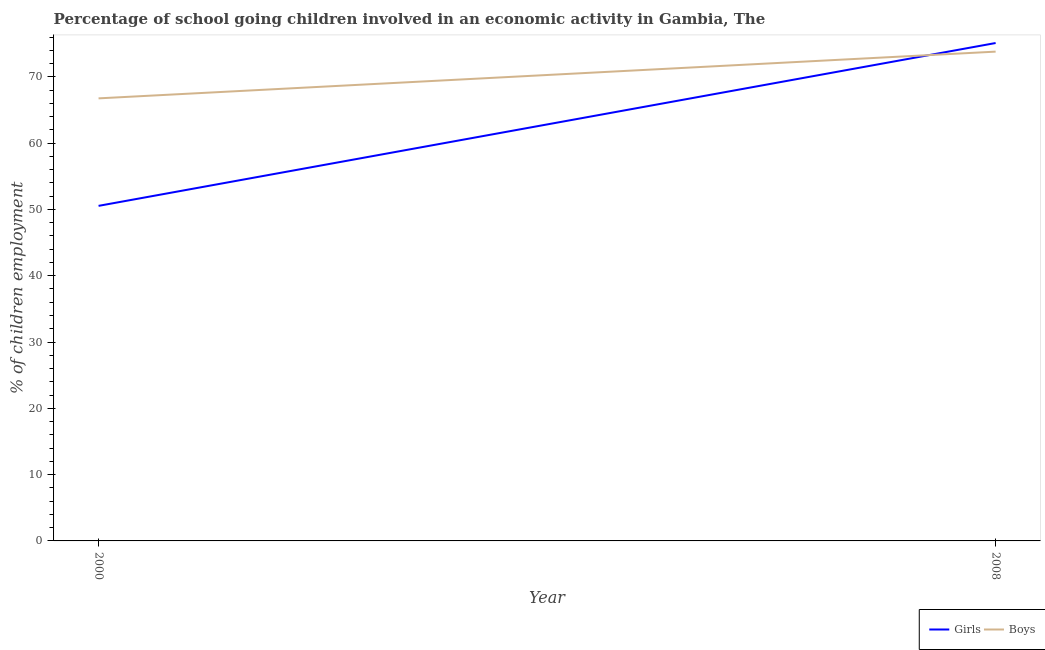How many different coloured lines are there?
Your answer should be very brief. 2. Does the line corresponding to percentage of school going boys intersect with the line corresponding to percentage of school going girls?
Provide a short and direct response. Yes. What is the percentage of school going girls in 2008?
Make the answer very short. 75.1. Across all years, what is the maximum percentage of school going boys?
Your answer should be very brief. 73.8. Across all years, what is the minimum percentage of school going girls?
Your answer should be compact. 50.54. What is the total percentage of school going boys in the graph?
Provide a succinct answer. 140.55. What is the difference between the percentage of school going boys in 2000 and that in 2008?
Make the answer very short. -7.05. What is the difference between the percentage of school going boys in 2008 and the percentage of school going girls in 2000?
Make the answer very short. 23.26. What is the average percentage of school going boys per year?
Your answer should be very brief. 70.28. In the year 2000, what is the difference between the percentage of school going boys and percentage of school going girls?
Give a very brief answer. 16.21. What is the ratio of the percentage of school going girls in 2000 to that in 2008?
Keep it short and to the point. 0.67. In how many years, is the percentage of school going girls greater than the average percentage of school going girls taken over all years?
Offer a terse response. 1. Does the percentage of school going boys monotonically increase over the years?
Your answer should be compact. Yes. How many lines are there?
Keep it short and to the point. 2. What is the difference between two consecutive major ticks on the Y-axis?
Provide a succinct answer. 10. Are the values on the major ticks of Y-axis written in scientific E-notation?
Provide a succinct answer. No. Does the graph contain any zero values?
Ensure brevity in your answer.  No. What is the title of the graph?
Your answer should be very brief. Percentage of school going children involved in an economic activity in Gambia, The. What is the label or title of the X-axis?
Ensure brevity in your answer.  Year. What is the label or title of the Y-axis?
Provide a succinct answer. % of children employment. What is the % of children employment in Girls in 2000?
Your answer should be compact. 50.54. What is the % of children employment of Boys in 2000?
Give a very brief answer. 66.75. What is the % of children employment in Girls in 2008?
Ensure brevity in your answer.  75.1. What is the % of children employment in Boys in 2008?
Offer a very short reply. 73.8. Across all years, what is the maximum % of children employment in Girls?
Provide a succinct answer. 75.1. Across all years, what is the maximum % of children employment of Boys?
Give a very brief answer. 73.8. Across all years, what is the minimum % of children employment in Girls?
Your response must be concise. 50.54. Across all years, what is the minimum % of children employment of Boys?
Give a very brief answer. 66.75. What is the total % of children employment in Girls in the graph?
Your answer should be compact. 125.64. What is the total % of children employment of Boys in the graph?
Provide a succinct answer. 140.55. What is the difference between the % of children employment in Girls in 2000 and that in 2008?
Provide a succinct answer. -24.56. What is the difference between the % of children employment in Boys in 2000 and that in 2008?
Give a very brief answer. -7.05. What is the difference between the % of children employment in Girls in 2000 and the % of children employment in Boys in 2008?
Provide a short and direct response. -23.26. What is the average % of children employment of Girls per year?
Provide a short and direct response. 62.82. What is the average % of children employment of Boys per year?
Provide a succinct answer. 70.28. In the year 2000, what is the difference between the % of children employment in Girls and % of children employment in Boys?
Offer a terse response. -16.21. What is the ratio of the % of children employment in Girls in 2000 to that in 2008?
Give a very brief answer. 0.67. What is the ratio of the % of children employment of Boys in 2000 to that in 2008?
Ensure brevity in your answer.  0.9. What is the difference between the highest and the second highest % of children employment in Girls?
Provide a succinct answer. 24.56. What is the difference between the highest and the second highest % of children employment of Boys?
Offer a very short reply. 7.05. What is the difference between the highest and the lowest % of children employment in Girls?
Provide a short and direct response. 24.56. What is the difference between the highest and the lowest % of children employment of Boys?
Offer a very short reply. 7.05. 